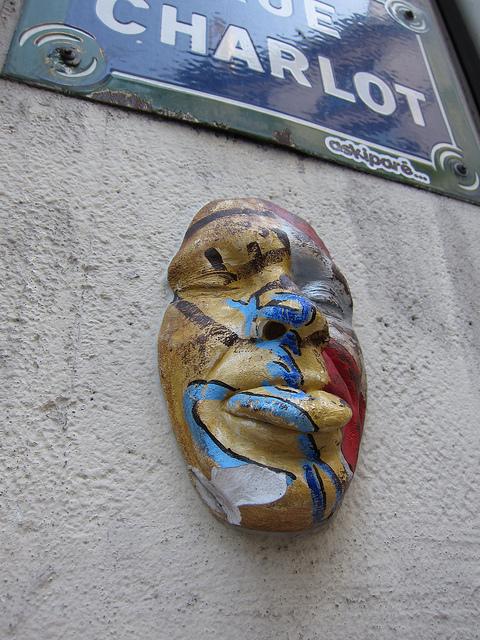Is this a real person?
Quick response, please. No. What word can you see in the picture?
Give a very brief answer. Charlotte. Would this sculpture be considered art?
Write a very short answer. Yes. 